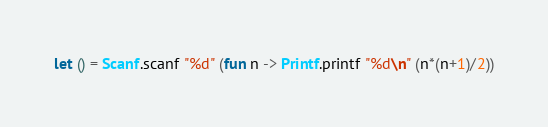<code> <loc_0><loc_0><loc_500><loc_500><_OCaml_>let () = Scanf.scanf "%d" (fun n -> Printf.printf "%d\n" (n*(n+1)/2))
</code> 